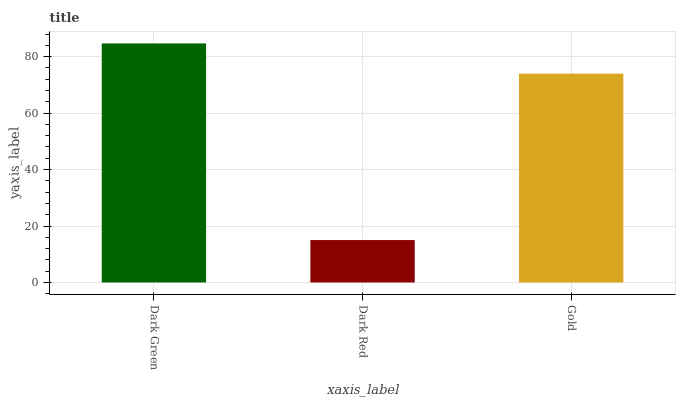Is Dark Red the minimum?
Answer yes or no. Yes. Is Dark Green the maximum?
Answer yes or no. Yes. Is Gold the minimum?
Answer yes or no. No. Is Gold the maximum?
Answer yes or no. No. Is Gold greater than Dark Red?
Answer yes or no. Yes. Is Dark Red less than Gold?
Answer yes or no. Yes. Is Dark Red greater than Gold?
Answer yes or no. No. Is Gold less than Dark Red?
Answer yes or no. No. Is Gold the high median?
Answer yes or no. Yes. Is Gold the low median?
Answer yes or no. Yes. Is Dark Green the high median?
Answer yes or no. No. Is Dark Green the low median?
Answer yes or no. No. 